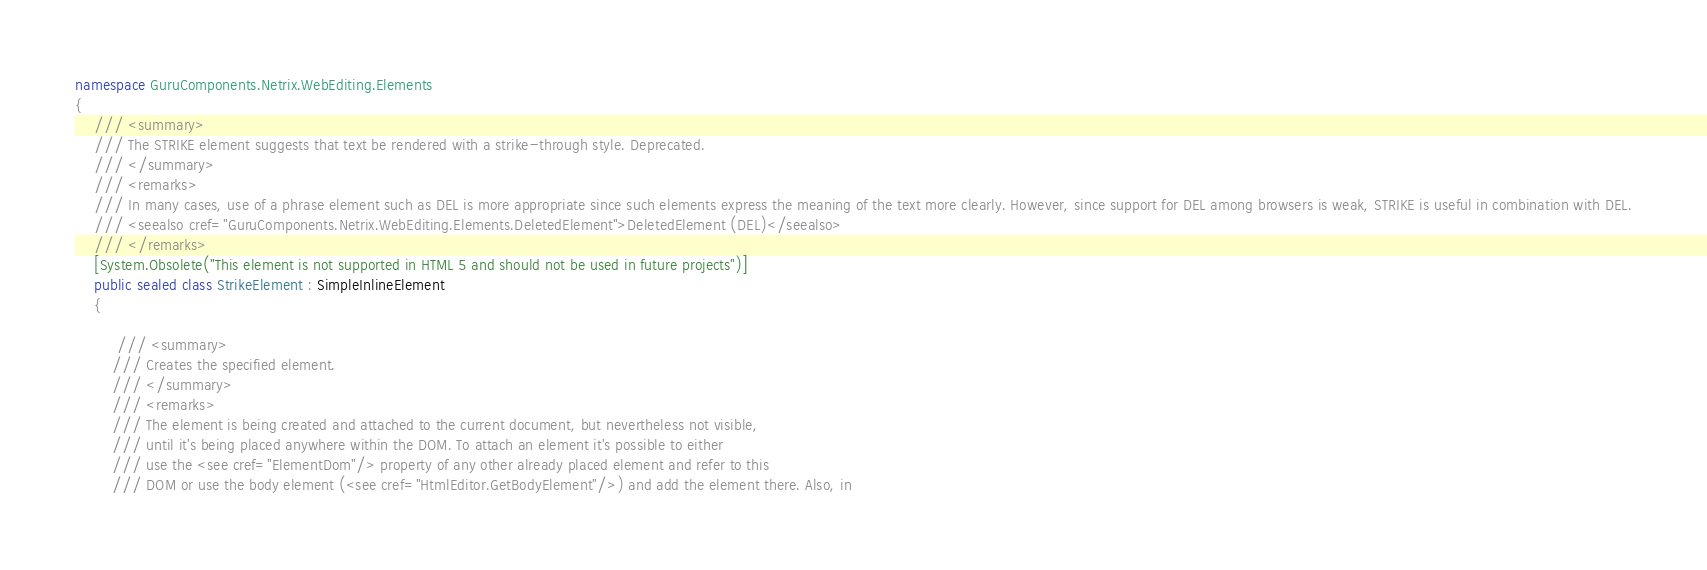Convert code to text. <code><loc_0><loc_0><loc_500><loc_500><_C#_>namespace GuruComponents.Netrix.WebEditing.Elements
{
    /// <summary>
    /// The STRIKE element suggests that text be rendered with a strike-through style. Deprecated.
    /// </summary>
    /// <remarks>
    /// In many cases, use of a phrase element such as DEL is more appropriate since such elements express the meaning of the text more clearly. However, since support for DEL among browsers is weak, STRIKE is useful in combination with DEL.
    /// <seealso cref="GuruComponents.Netrix.WebEditing.Elements.DeletedElement">DeletedElement (DEL)</seealso>
    /// </remarks>
    [System.Obsolete("This element is not supported in HTML 5 and should not be used in future projects")]
    public sealed class StrikeElement : SimpleInlineElement
    {

         /// <summary>
        /// Creates the specified element.
        /// </summary>
        /// <remarks>
        /// The element is being created and attached to the current document, but nevertheless not visible,
        /// until it's being placed anywhere within the DOM. To attach an element it's possible to either
        /// use the <see cref="ElementDom"/> property of any other already placed element and refer to this
        /// DOM or use the body element (<see cref="HtmlEditor.GetBodyElement"/>) and add the element there. Also, in </code> 